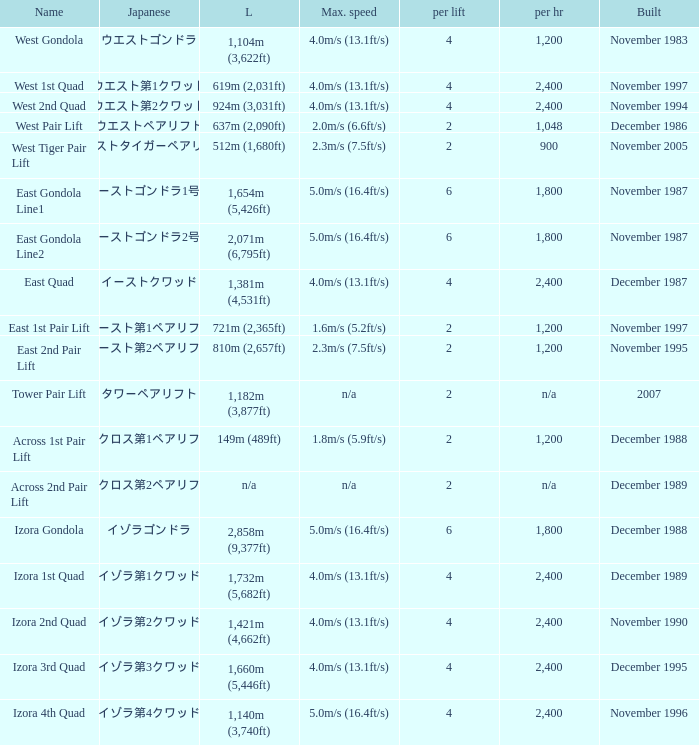How heavy is the  maximum 6.0. 